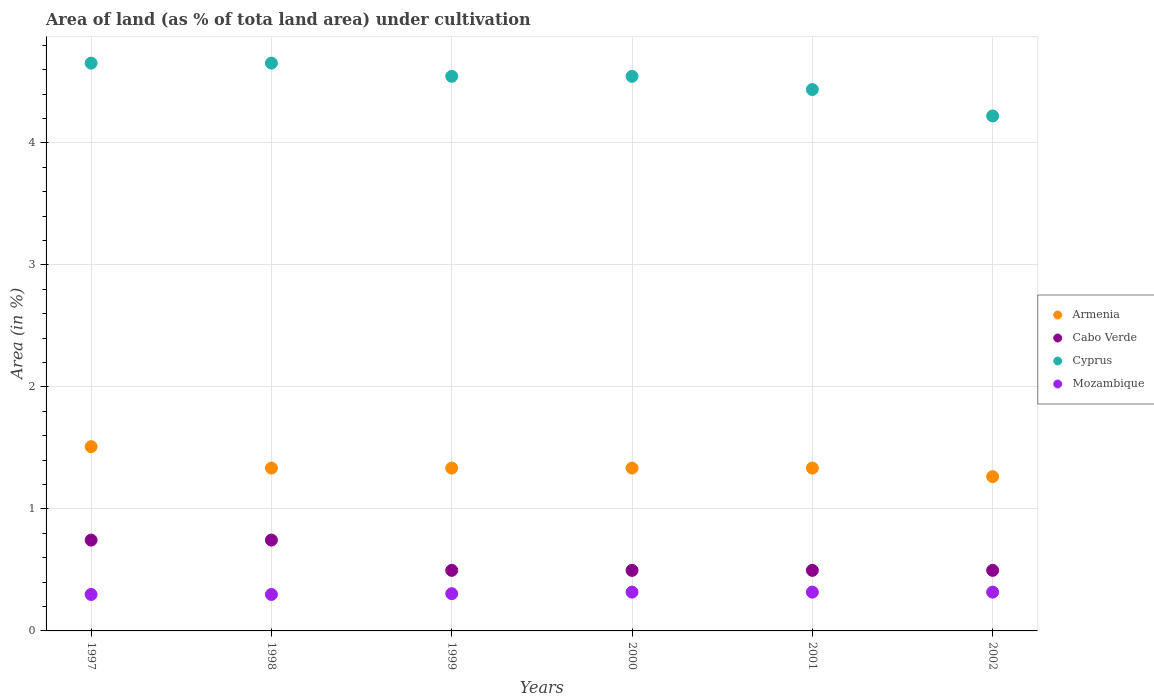What is the percentage of land under cultivation in Mozambique in 1997?
Make the answer very short. 0.3. Across all years, what is the maximum percentage of land under cultivation in Cyprus?
Provide a succinct answer. 4.65. Across all years, what is the minimum percentage of land under cultivation in Cyprus?
Your answer should be compact. 4.22. What is the total percentage of land under cultivation in Armenia in the graph?
Offer a terse response. 8.11. What is the difference between the percentage of land under cultivation in Mozambique in 1997 and that in 2002?
Your answer should be compact. -0.02. What is the difference between the percentage of land under cultivation in Cyprus in 1998 and the percentage of land under cultivation in Cabo Verde in 2000?
Your answer should be compact. 4.16. What is the average percentage of land under cultivation in Armenia per year?
Give a very brief answer. 1.35. In the year 1998, what is the difference between the percentage of land under cultivation in Mozambique and percentage of land under cultivation in Cyprus?
Give a very brief answer. -4.35. What is the ratio of the percentage of land under cultivation in Cabo Verde in 1999 to that in 2000?
Your answer should be compact. 1. What is the difference between the highest and the second highest percentage of land under cultivation in Armenia?
Provide a succinct answer. 0.18. What is the difference between the highest and the lowest percentage of land under cultivation in Mozambique?
Provide a succinct answer. 0.02. In how many years, is the percentage of land under cultivation in Mozambique greater than the average percentage of land under cultivation in Mozambique taken over all years?
Make the answer very short. 3. Is the sum of the percentage of land under cultivation in Cabo Verde in 1997 and 1998 greater than the maximum percentage of land under cultivation in Mozambique across all years?
Provide a short and direct response. Yes. Is the percentage of land under cultivation in Armenia strictly greater than the percentage of land under cultivation in Cabo Verde over the years?
Give a very brief answer. Yes. How many years are there in the graph?
Keep it short and to the point. 6. What is the difference between two consecutive major ticks on the Y-axis?
Your answer should be very brief. 1. Are the values on the major ticks of Y-axis written in scientific E-notation?
Provide a short and direct response. No. Does the graph contain grids?
Your response must be concise. Yes. Where does the legend appear in the graph?
Offer a very short reply. Center right. How are the legend labels stacked?
Make the answer very short. Vertical. What is the title of the graph?
Make the answer very short. Area of land (as % of tota land area) under cultivation. Does "San Marino" appear as one of the legend labels in the graph?
Provide a short and direct response. No. What is the label or title of the Y-axis?
Offer a terse response. Area (in %). What is the Area (in %) of Armenia in 1997?
Provide a short and direct response. 1.51. What is the Area (in %) in Cabo Verde in 1997?
Your answer should be compact. 0.74. What is the Area (in %) of Cyprus in 1997?
Your answer should be compact. 4.65. What is the Area (in %) of Mozambique in 1997?
Keep it short and to the point. 0.3. What is the Area (in %) in Armenia in 1998?
Offer a terse response. 1.33. What is the Area (in %) of Cabo Verde in 1998?
Your response must be concise. 0.74. What is the Area (in %) in Cyprus in 1998?
Your answer should be compact. 4.65. What is the Area (in %) in Mozambique in 1998?
Offer a terse response. 0.3. What is the Area (in %) in Armenia in 1999?
Offer a very short reply. 1.33. What is the Area (in %) of Cabo Verde in 1999?
Ensure brevity in your answer.  0.5. What is the Area (in %) of Cyprus in 1999?
Give a very brief answer. 4.55. What is the Area (in %) in Mozambique in 1999?
Provide a short and direct response. 0.31. What is the Area (in %) of Armenia in 2000?
Your answer should be compact. 1.33. What is the Area (in %) of Cabo Verde in 2000?
Make the answer very short. 0.5. What is the Area (in %) of Cyprus in 2000?
Ensure brevity in your answer.  4.55. What is the Area (in %) of Mozambique in 2000?
Ensure brevity in your answer.  0.32. What is the Area (in %) of Armenia in 2001?
Give a very brief answer. 1.33. What is the Area (in %) of Cabo Verde in 2001?
Your answer should be compact. 0.5. What is the Area (in %) in Cyprus in 2001?
Give a very brief answer. 4.44. What is the Area (in %) in Mozambique in 2001?
Provide a succinct answer. 0.32. What is the Area (in %) in Armenia in 2002?
Make the answer very short. 1.26. What is the Area (in %) in Cabo Verde in 2002?
Offer a very short reply. 0.5. What is the Area (in %) in Cyprus in 2002?
Provide a short and direct response. 4.22. What is the Area (in %) of Mozambique in 2002?
Keep it short and to the point. 0.32. Across all years, what is the maximum Area (in %) of Armenia?
Provide a succinct answer. 1.51. Across all years, what is the maximum Area (in %) in Cabo Verde?
Offer a terse response. 0.74. Across all years, what is the maximum Area (in %) in Cyprus?
Offer a very short reply. 4.65. Across all years, what is the maximum Area (in %) of Mozambique?
Offer a terse response. 0.32. Across all years, what is the minimum Area (in %) in Armenia?
Ensure brevity in your answer.  1.26. Across all years, what is the minimum Area (in %) of Cabo Verde?
Keep it short and to the point. 0.5. Across all years, what is the minimum Area (in %) in Cyprus?
Keep it short and to the point. 4.22. Across all years, what is the minimum Area (in %) of Mozambique?
Give a very brief answer. 0.3. What is the total Area (in %) in Armenia in the graph?
Offer a terse response. 8.11. What is the total Area (in %) of Cabo Verde in the graph?
Your answer should be very brief. 3.47. What is the total Area (in %) in Cyprus in the graph?
Your response must be concise. 27.06. What is the total Area (in %) in Mozambique in the graph?
Your answer should be compact. 1.86. What is the difference between the Area (in %) of Armenia in 1997 and that in 1998?
Give a very brief answer. 0.18. What is the difference between the Area (in %) in Armenia in 1997 and that in 1999?
Provide a short and direct response. 0.18. What is the difference between the Area (in %) of Cabo Verde in 1997 and that in 1999?
Offer a very short reply. 0.25. What is the difference between the Area (in %) in Cyprus in 1997 and that in 1999?
Your response must be concise. 0.11. What is the difference between the Area (in %) of Mozambique in 1997 and that in 1999?
Provide a succinct answer. -0.01. What is the difference between the Area (in %) in Armenia in 1997 and that in 2000?
Give a very brief answer. 0.18. What is the difference between the Area (in %) in Cabo Verde in 1997 and that in 2000?
Provide a short and direct response. 0.25. What is the difference between the Area (in %) of Cyprus in 1997 and that in 2000?
Your response must be concise. 0.11. What is the difference between the Area (in %) of Mozambique in 1997 and that in 2000?
Offer a terse response. -0.02. What is the difference between the Area (in %) in Armenia in 1997 and that in 2001?
Keep it short and to the point. 0.18. What is the difference between the Area (in %) in Cabo Verde in 1997 and that in 2001?
Your answer should be compact. 0.25. What is the difference between the Area (in %) of Cyprus in 1997 and that in 2001?
Your answer should be very brief. 0.22. What is the difference between the Area (in %) in Mozambique in 1997 and that in 2001?
Give a very brief answer. -0.02. What is the difference between the Area (in %) of Armenia in 1997 and that in 2002?
Ensure brevity in your answer.  0.25. What is the difference between the Area (in %) of Cabo Verde in 1997 and that in 2002?
Your answer should be compact. 0.25. What is the difference between the Area (in %) of Cyprus in 1997 and that in 2002?
Your response must be concise. 0.43. What is the difference between the Area (in %) of Mozambique in 1997 and that in 2002?
Make the answer very short. -0.02. What is the difference between the Area (in %) in Armenia in 1998 and that in 1999?
Your response must be concise. 0. What is the difference between the Area (in %) of Cabo Verde in 1998 and that in 1999?
Ensure brevity in your answer.  0.25. What is the difference between the Area (in %) in Cyprus in 1998 and that in 1999?
Offer a very short reply. 0.11. What is the difference between the Area (in %) in Mozambique in 1998 and that in 1999?
Give a very brief answer. -0.01. What is the difference between the Area (in %) in Cabo Verde in 1998 and that in 2000?
Your response must be concise. 0.25. What is the difference between the Area (in %) in Cyprus in 1998 and that in 2000?
Your response must be concise. 0.11. What is the difference between the Area (in %) in Mozambique in 1998 and that in 2000?
Provide a succinct answer. -0.02. What is the difference between the Area (in %) in Armenia in 1998 and that in 2001?
Offer a terse response. 0. What is the difference between the Area (in %) in Cabo Verde in 1998 and that in 2001?
Offer a terse response. 0.25. What is the difference between the Area (in %) in Cyprus in 1998 and that in 2001?
Offer a terse response. 0.22. What is the difference between the Area (in %) of Mozambique in 1998 and that in 2001?
Provide a succinct answer. -0.02. What is the difference between the Area (in %) of Armenia in 1998 and that in 2002?
Give a very brief answer. 0.07. What is the difference between the Area (in %) in Cabo Verde in 1998 and that in 2002?
Offer a terse response. 0.25. What is the difference between the Area (in %) in Cyprus in 1998 and that in 2002?
Provide a short and direct response. 0.43. What is the difference between the Area (in %) in Mozambique in 1998 and that in 2002?
Offer a terse response. -0.02. What is the difference between the Area (in %) in Armenia in 1999 and that in 2000?
Make the answer very short. 0. What is the difference between the Area (in %) in Cabo Verde in 1999 and that in 2000?
Your answer should be very brief. 0. What is the difference between the Area (in %) in Cyprus in 1999 and that in 2000?
Give a very brief answer. 0. What is the difference between the Area (in %) of Mozambique in 1999 and that in 2000?
Your answer should be very brief. -0.01. What is the difference between the Area (in %) in Armenia in 1999 and that in 2001?
Make the answer very short. 0. What is the difference between the Area (in %) of Cabo Verde in 1999 and that in 2001?
Provide a succinct answer. 0. What is the difference between the Area (in %) of Cyprus in 1999 and that in 2001?
Offer a very short reply. 0.11. What is the difference between the Area (in %) in Mozambique in 1999 and that in 2001?
Your answer should be compact. -0.01. What is the difference between the Area (in %) in Armenia in 1999 and that in 2002?
Your answer should be very brief. 0.07. What is the difference between the Area (in %) in Cyprus in 1999 and that in 2002?
Give a very brief answer. 0.32. What is the difference between the Area (in %) of Mozambique in 1999 and that in 2002?
Provide a short and direct response. -0.01. What is the difference between the Area (in %) of Cyprus in 2000 and that in 2001?
Your answer should be compact. 0.11. What is the difference between the Area (in %) in Mozambique in 2000 and that in 2001?
Ensure brevity in your answer.  0. What is the difference between the Area (in %) of Armenia in 2000 and that in 2002?
Offer a very short reply. 0.07. What is the difference between the Area (in %) of Cyprus in 2000 and that in 2002?
Offer a terse response. 0.32. What is the difference between the Area (in %) of Armenia in 2001 and that in 2002?
Provide a short and direct response. 0.07. What is the difference between the Area (in %) in Cyprus in 2001 and that in 2002?
Offer a terse response. 0.22. What is the difference between the Area (in %) in Mozambique in 2001 and that in 2002?
Your answer should be compact. 0. What is the difference between the Area (in %) of Armenia in 1997 and the Area (in %) of Cabo Verde in 1998?
Offer a terse response. 0.77. What is the difference between the Area (in %) of Armenia in 1997 and the Area (in %) of Cyprus in 1998?
Your answer should be compact. -3.14. What is the difference between the Area (in %) of Armenia in 1997 and the Area (in %) of Mozambique in 1998?
Provide a short and direct response. 1.21. What is the difference between the Area (in %) of Cabo Verde in 1997 and the Area (in %) of Cyprus in 1998?
Ensure brevity in your answer.  -3.91. What is the difference between the Area (in %) of Cabo Verde in 1997 and the Area (in %) of Mozambique in 1998?
Provide a succinct answer. 0.45. What is the difference between the Area (in %) of Cyprus in 1997 and the Area (in %) of Mozambique in 1998?
Offer a terse response. 4.35. What is the difference between the Area (in %) in Armenia in 1997 and the Area (in %) in Cabo Verde in 1999?
Offer a terse response. 1.01. What is the difference between the Area (in %) in Armenia in 1997 and the Area (in %) in Cyprus in 1999?
Your response must be concise. -3.04. What is the difference between the Area (in %) of Armenia in 1997 and the Area (in %) of Mozambique in 1999?
Provide a succinct answer. 1.21. What is the difference between the Area (in %) in Cabo Verde in 1997 and the Area (in %) in Cyprus in 1999?
Your answer should be compact. -3.8. What is the difference between the Area (in %) of Cabo Verde in 1997 and the Area (in %) of Mozambique in 1999?
Ensure brevity in your answer.  0.44. What is the difference between the Area (in %) in Cyprus in 1997 and the Area (in %) in Mozambique in 1999?
Provide a short and direct response. 4.35. What is the difference between the Area (in %) of Armenia in 1997 and the Area (in %) of Cabo Verde in 2000?
Offer a very short reply. 1.01. What is the difference between the Area (in %) in Armenia in 1997 and the Area (in %) in Cyprus in 2000?
Offer a very short reply. -3.04. What is the difference between the Area (in %) of Armenia in 1997 and the Area (in %) of Mozambique in 2000?
Offer a terse response. 1.19. What is the difference between the Area (in %) in Cabo Verde in 1997 and the Area (in %) in Cyprus in 2000?
Provide a succinct answer. -3.8. What is the difference between the Area (in %) of Cabo Verde in 1997 and the Area (in %) of Mozambique in 2000?
Provide a short and direct response. 0.43. What is the difference between the Area (in %) in Cyprus in 1997 and the Area (in %) in Mozambique in 2000?
Provide a succinct answer. 4.34. What is the difference between the Area (in %) in Armenia in 1997 and the Area (in %) in Cabo Verde in 2001?
Your response must be concise. 1.01. What is the difference between the Area (in %) of Armenia in 1997 and the Area (in %) of Cyprus in 2001?
Your answer should be compact. -2.93. What is the difference between the Area (in %) in Armenia in 1997 and the Area (in %) in Mozambique in 2001?
Give a very brief answer. 1.19. What is the difference between the Area (in %) of Cabo Verde in 1997 and the Area (in %) of Cyprus in 2001?
Offer a terse response. -3.69. What is the difference between the Area (in %) of Cabo Verde in 1997 and the Area (in %) of Mozambique in 2001?
Give a very brief answer. 0.43. What is the difference between the Area (in %) of Cyprus in 1997 and the Area (in %) of Mozambique in 2001?
Provide a succinct answer. 4.34. What is the difference between the Area (in %) of Armenia in 1997 and the Area (in %) of Cabo Verde in 2002?
Offer a terse response. 1.01. What is the difference between the Area (in %) of Armenia in 1997 and the Area (in %) of Cyprus in 2002?
Provide a succinct answer. -2.71. What is the difference between the Area (in %) in Armenia in 1997 and the Area (in %) in Mozambique in 2002?
Provide a short and direct response. 1.19. What is the difference between the Area (in %) in Cabo Verde in 1997 and the Area (in %) in Cyprus in 2002?
Ensure brevity in your answer.  -3.48. What is the difference between the Area (in %) of Cabo Verde in 1997 and the Area (in %) of Mozambique in 2002?
Your answer should be very brief. 0.43. What is the difference between the Area (in %) in Cyprus in 1997 and the Area (in %) in Mozambique in 2002?
Ensure brevity in your answer.  4.34. What is the difference between the Area (in %) of Armenia in 1998 and the Area (in %) of Cabo Verde in 1999?
Keep it short and to the point. 0.84. What is the difference between the Area (in %) of Armenia in 1998 and the Area (in %) of Cyprus in 1999?
Offer a very short reply. -3.21. What is the difference between the Area (in %) of Armenia in 1998 and the Area (in %) of Mozambique in 1999?
Ensure brevity in your answer.  1.03. What is the difference between the Area (in %) in Cabo Verde in 1998 and the Area (in %) in Cyprus in 1999?
Offer a terse response. -3.8. What is the difference between the Area (in %) in Cabo Verde in 1998 and the Area (in %) in Mozambique in 1999?
Provide a succinct answer. 0.44. What is the difference between the Area (in %) of Cyprus in 1998 and the Area (in %) of Mozambique in 1999?
Your response must be concise. 4.35. What is the difference between the Area (in %) of Armenia in 1998 and the Area (in %) of Cabo Verde in 2000?
Offer a terse response. 0.84. What is the difference between the Area (in %) in Armenia in 1998 and the Area (in %) in Cyprus in 2000?
Provide a succinct answer. -3.21. What is the difference between the Area (in %) in Armenia in 1998 and the Area (in %) in Mozambique in 2000?
Offer a very short reply. 1.02. What is the difference between the Area (in %) of Cabo Verde in 1998 and the Area (in %) of Cyprus in 2000?
Keep it short and to the point. -3.8. What is the difference between the Area (in %) in Cabo Verde in 1998 and the Area (in %) in Mozambique in 2000?
Keep it short and to the point. 0.43. What is the difference between the Area (in %) of Cyprus in 1998 and the Area (in %) of Mozambique in 2000?
Ensure brevity in your answer.  4.34. What is the difference between the Area (in %) in Armenia in 1998 and the Area (in %) in Cabo Verde in 2001?
Your answer should be very brief. 0.84. What is the difference between the Area (in %) of Armenia in 1998 and the Area (in %) of Cyprus in 2001?
Give a very brief answer. -3.1. What is the difference between the Area (in %) of Armenia in 1998 and the Area (in %) of Mozambique in 2001?
Your answer should be compact. 1.02. What is the difference between the Area (in %) in Cabo Verde in 1998 and the Area (in %) in Cyprus in 2001?
Your answer should be compact. -3.69. What is the difference between the Area (in %) of Cabo Verde in 1998 and the Area (in %) of Mozambique in 2001?
Provide a succinct answer. 0.43. What is the difference between the Area (in %) in Cyprus in 1998 and the Area (in %) in Mozambique in 2001?
Keep it short and to the point. 4.34. What is the difference between the Area (in %) in Armenia in 1998 and the Area (in %) in Cabo Verde in 2002?
Give a very brief answer. 0.84. What is the difference between the Area (in %) of Armenia in 1998 and the Area (in %) of Cyprus in 2002?
Offer a very short reply. -2.89. What is the difference between the Area (in %) of Armenia in 1998 and the Area (in %) of Mozambique in 2002?
Make the answer very short. 1.02. What is the difference between the Area (in %) in Cabo Verde in 1998 and the Area (in %) in Cyprus in 2002?
Your response must be concise. -3.48. What is the difference between the Area (in %) in Cabo Verde in 1998 and the Area (in %) in Mozambique in 2002?
Your answer should be compact. 0.43. What is the difference between the Area (in %) of Cyprus in 1998 and the Area (in %) of Mozambique in 2002?
Your answer should be very brief. 4.34. What is the difference between the Area (in %) in Armenia in 1999 and the Area (in %) in Cabo Verde in 2000?
Give a very brief answer. 0.84. What is the difference between the Area (in %) in Armenia in 1999 and the Area (in %) in Cyprus in 2000?
Your response must be concise. -3.21. What is the difference between the Area (in %) in Armenia in 1999 and the Area (in %) in Mozambique in 2000?
Your response must be concise. 1.02. What is the difference between the Area (in %) in Cabo Verde in 1999 and the Area (in %) in Cyprus in 2000?
Give a very brief answer. -4.05. What is the difference between the Area (in %) of Cabo Verde in 1999 and the Area (in %) of Mozambique in 2000?
Your answer should be compact. 0.18. What is the difference between the Area (in %) of Cyprus in 1999 and the Area (in %) of Mozambique in 2000?
Offer a very short reply. 4.23. What is the difference between the Area (in %) of Armenia in 1999 and the Area (in %) of Cabo Verde in 2001?
Your response must be concise. 0.84. What is the difference between the Area (in %) of Armenia in 1999 and the Area (in %) of Cyprus in 2001?
Offer a terse response. -3.1. What is the difference between the Area (in %) in Armenia in 1999 and the Area (in %) in Mozambique in 2001?
Make the answer very short. 1.02. What is the difference between the Area (in %) in Cabo Verde in 1999 and the Area (in %) in Cyprus in 2001?
Ensure brevity in your answer.  -3.94. What is the difference between the Area (in %) of Cabo Verde in 1999 and the Area (in %) of Mozambique in 2001?
Provide a short and direct response. 0.18. What is the difference between the Area (in %) in Cyprus in 1999 and the Area (in %) in Mozambique in 2001?
Provide a short and direct response. 4.23. What is the difference between the Area (in %) of Armenia in 1999 and the Area (in %) of Cabo Verde in 2002?
Ensure brevity in your answer.  0.84. What is the difference between the Area (in %) of Armenia in 1999 and the Area (in %) of Cyprus in 2002?
Provide a succinct answer. -2.89. What is the difference between the Area (in %) of Armenia in 1999 and the Area (in %) of Mozambique in 2002?
Offer a very short reply. 1.02. What is the difference between the Area (in %) in Cabo Verde in 1999 and the Area (in %) in Cyprus in 2002?
Your answer should be compact. -3.72. What is the difference between the Area (in %) of Cabo Verde in 1999 and the Area (in %) of Mozambique in 2002?
Keep it short and to the point. 0.18. What is the difference between the Area (in %) in Cyprus in 1999 and the Area (in %) in Mozambique in 2002?
Offer a very short reply. 4.23. What is the difference between the Area (in %) of Armenia in 2000 and the Area (in %) of Cabo Verde in 2001?
Make the answer very short. 0.84. What is the difference between the Area (in %) in Armenia in 2000 and the Area (in %) in Cyprus in 2001?
Provide a succinct answer. -3.1. What is the difference between the Area (in %) of Armenia in 2000 and the Area (in %) of Mozambique in 2001?
Offer a very short reply. 1.02. What is the difference between the Area (in %) in Cabo Verde in 2000 and the Area (in %) in Cyprus in 2001?
Provide a short and direct response. -3.94. What is the difference between the Area (in %) of Cabo Verde in 2000 and the Area (in %) of Mozambique in 2001?
Offer a terse response. 0.18. What is the difference between the Area (in %) of Cyprus in 2000 and the Area (in %) of Mozambique in 2001?
Your response must be concise. 4.23. What is the difference between the Area (in %) in Armenia in 2000 and the Area (in %) in Cabo Verde in 2002?
Provide a succinct answer. 0.84. What is the difference between the Area (in %) of Armenia in 2000 and the Area (in %) of Cyprus in 2002?
Your answer should be very brief. -2.89. What is the difference between the Area (in %) of Armenia in 2000 and the Area (in %) of Mozambique in 2002?
Give a very brief answer. 1.02. What is the difference between the Area (in %) of Cabo Verde in 2000 and the Area (in %) of Cyprus in 2002?
Your answer should be compact. -3.72. What is the difference between the Area (in %) of Cabo Verde in 2000 and the Area (in %) of Mozambique in 2002?
Provide a succinct answer. 0.18. What is the difference between the Area (in %) of Cyprus in 2000 and the Area (in %) of Mozambique in 2002?
Provide a short and direct response. 4.23. What is the difference between the Area (in %) in Armenia in 2001 and the Area (in %) in Cabo Verde in 2002?
Your answer should be very brief. 0.84. What is the difference between the Area (in %) in Armenia in 2001 and the Area (in %) in Cyprus in 2002?
Ensure brevity in your answer.  -2.89. What is the difference between the Area (in %) in Armenia in 2001 and the Area (in %) in Mozambique in 2002?
Provide a succinct answer. 1.02. What is the difference between the Area (in %) of Cabo Verde in 2001 and the Area (in %) of Cyprus in 2002?
Offer a very short reply. -3.72. What is the difference between the Area (in %) in Cabo Verde in 2001 and the Area (in %) in Mozambique in 2002?
Offer a very short reply. 0.18. What is the difference between the Area (in %) of Cyprus in 2001 and the Area (in %) of Mozambique in 2002?
Your answer should be compact. 4.12. What is the average Area (in %) in Armenia per year?
Your answer should be compact. 1.35. What is the average Area (in %) in Cabo Verde per year?
Make the answer very short. 0.58. What is the average Area (in %) of Cyprus per year?
Provide a short and direct response. 4.51. What is the average Area (in %) of Mozambique per year?
Give a very brief answer. 0.31. In the year 1997, what is the difference between the Area (in %) in Armenia and Area (in %) in Cabo Verde?
Offer a terse response. 0.77. In the year 1997, what is the difference between the Area (in %) in Armenia and Area (in %) in Cyprus?
Offer a very short reply. -3.14. In the year 1997, what is the difference between the Area (in %) in Armenia and Area (in %) in Mozambique?
Your answer should be compact. 1.21. In the year 1997, what is the difference between the Area (in %) in Cabo Verde and Area (in %) in Cyprus?
Your answer should be very brief. -3.91. In the year 1997, what is the difference between the Area (in %) in Cabo Verde and Area (in %) in Mozambique?
Give a very brief answer. 0.45. In the year 1997, what is the difference between the Area (in %) in Cyprus and Area (in %) in Mozambique?
Give a very brief answer. 4.35. In the year 1998, what is the difference between the Area (in %) in Armenia and Area (in %) in Cabo Verde?
Keep it short and to the point. 0.59. In the year 1998, what is the difference between the Area (in %) in Armenia and Area (in %) in Cyprus?
Give a very brief answer. -3.32. In the year 1998, what is the difference between the Area (in %) of Armenia and Area (in %) of Mozambique?
Provide a succinct answer. 1.04. In the year 1998, what is the difference between the Area (in %) in Cabo Verde and Area (in %) in Cyprus?
Give a very brief answer. -3.91. In the year 1998, what is the difference between the Area (in %) of Cabo Verde and Area (in %) of Mozambique?
Provide a short and direct response. 0.45. In the year 1998, what is the difference between the Area (in %) in Cyprus and Area (in %) in Mozambique?
Offer a terse response. 4.35. In the year 1999, what is the difference between the Area (in %) of Armenia and Area (in %) of Cabo Verde?
Provide a short and direct response. 0.84. In the year 1999, what is the difference between the Area (in %) of Armenia and Area (in %) of Cyprus?
Your response must be concise. -3.21. In the year 1999, what is the difference between the Area (in %) of Armenia and Area (in %) of Mozambique?
Provide a succinct answer. 1.03. In the year 1999, what is the difference between the Area (in %) of Cabo Verde and Area (in %) of Cyprus?
Your response must be concise. -4.05. In the year 1999, what is the difference between the Area (in %) in Cabo Verde and Area (in %) in Mozambique?
Provide a short and direct response. 0.19. In the year 1999, what is the difference between the Area (in %) in Cyprus and Area (in %) in Mozambique?
Your answer should be very brief. 4.24. In the year 2000, what is the difference between the Area (in %) of Armenia and Area (in %) of Cabo Verde?
Provide a short and direct response. 0.84. In the year 2000, what is the difference between the Area (in %) in Armenia and Area (in %) in Cyprus?
Ensure brevity in your answer.  -3.21. In the year 2000, what is the difference between the Area (in %) in Armenia and Area (in %) in Mozambique?
Ensure brevity in your answer.  1.02. In the year 2000, what is the difference between the Area (in %) in Cabo Verde and Area (in %) in Cyprus?
Your answer should be very brief. -4.05. In the year 2000, what is the difference between the Area (in %) in Cabo Verde and Area (in %) in Mozambique?
Provide a succinct answer. 0.18. In the year 2000, what is the difference between the Area (in %) of Cyprus and Area (in %) of Mozambique?
Give a very brief answer. 4.23. In the year 2001, what is the difference between the Area (in %) in Armenia and Area (in %) in Cabo Verde?
Offer a terse response. 0.84. In the year 2001, what is the difference between the Area (in %) of Armenia and Area (in %) of Cyprus?
Give a very brief answer. -3.1. In the year 2001, what is the difference between the Area (in %) of Armenia and Area (in %) of Mozambique?
Give a very brief answer. 1.02. In the year 2001, what is the difference between the Area (in %) in Cabo Verde and Area (in %) in Cyprus?
Offer a very short reply. -3.94. In the year 2001, what is the difference between the Area (in %) of Cabo Verde and Area (in %) of Mozambique?
Give a very brief answer. 0.18. In the year 2001, what is the difference between the Area (in %) in Cyprus and Area (in %) in Mozambique?
Offer a terse response. 4.12. In the year 2002, what is the difference between the Area (in %) in Armenia and Area (in %) in Cabo Verde?
Your answer should be compact. 0.77. In the year 2002, what is the difference between the Area (in %) in Armenia and Area (in %) in Cyprus?
Provide a short and direct response. -2.96. In the year 2002, what is the difference between the Area (in %) in Armenia and Area (in %) in Mozambique?
Provide a short and direct response. 0.95. In the year 2002, what is the difference between the Area (in %) in Cabo Verde and Area (in %) in Cyprus?
Make the answer very short. -3.72. In the year 2002, what is the difference between the Area (in %) of Cabo Verde and Area (in %) of Mozambique?
Provide a short and direct response. 0.18. In the year 2002, what is the difference between the Area (in %) of Cyprus and Area (in %) of Mozambique?
Offer a very short reply. 3.9. What is the ratio of the Area (in %) of Armenia in 1997 to that in 1998?
Provide a short and direct response. 1.13. What is the ratio of the Area (in %) of Cabo Verde in 1997 to that in 1998?
Keep it short and to the point. 1. What is the ratio of the Area (in %) of Cyprus in 1997 to that in 1998?
Offer a very short reply. 1. What is the ratio of the Area (in %) of Armenia in 1997 to that in 1999?
Your answer should be very brief. 1.13. What is the ratio of the Area (in %) of Cyprus in 1997 to that in 1999?
Offer a very short reply. 1.02. What is the ratio of the Area (in %) of Mozambique in 1997 to that in 1999?
Ensure brevity in your answer.  0.98. What is the ratio of the Area (in %) of Armenia in 1997 to that in 2000?
Your answer should be compact. 1.13. What is the ratio of the Area (in %) of Cabo Verde in 1997 to that in 2000?
Offer a terse response. 1.5. What is the ratio of the Area (in %) of Cyprus in 1997 to that in 2000?
Your response must be concise. 1.02. What is the ratio of the Area (in %) in Mozambique in 1997 to that in 2000?
Your answer should be compact. 0.94. What is the ratio of the Area (in %) in Armenia in 1997 to that in 2001?
Provide a succinct answer. 1.13. What is the ratio of the Area (in %) in Cabo Verde in 1997 to that in 2001?
Provide a short and direct response. 1.5. What is the ratio of the Area (in %) in Cyprus in 1997 to that in 2001?
Your response must be concise. 1.05. What is the ratio of the Area (in %) in Armenia in 1997 to that in 2002?
Offer a terse response. 1.19. What is the ratio of the Area (in %) of Cabo Verde in 1997 to that in 2002?
Your answer should be very brief. 1.5. What is the ratio of the Area (in %) in Cyprus in 1997 to that in 2002?
Keep it short and to the point. 1.1. What is the ratio of the Area (in %) of Mozambique in 1997 to that in 2002?
Ensure brevity in your answer.  0.94. What is the ratio of the Area (in %) in Armenia in 1998 to that in 1999?
Offer a terse response. 1. What is the ratio of the Area (in %) in Cabo Verde in 1998 to that in 1999?
Provide a short and direct response. 1.5. What is the ratio of the Area (in %) in Cyprus in 1998 to that in 1999?
Your answer should be very brief. 1.02. What is the ratio of the Area (in %) in Mozambique in 1998 to that in 1999?
Offer a very short reply. 0.98. What is the ratio of the Area (in %) in Cyprus in 1998 to that in 2000?
Your answer should be very brief. 1.02. What is the ratio of the Area (in %) in Mozambique in 1998 to that in 2000?
Keep it short and to the point. 0.94. What is the ratio of the Area (in %) of Cabo Verde in 1998 to that in 2001?
Provide a short and direct response. 1.5. What is the ratio of the Area (in %) in Cyprus in 1998 to that in 2001?
Offer a very short reply. 1.05. What is the ratio of the Area (in %) of Armenia in 1998 to that in 2002?
Make the answer very short. 1.06. What is the ratio of the Area (in %) of Cyprus in 1998 to that in 2002?
Your response must be concise. 1.1. What is the ratio of the Area (in %) of Mozambique in 1998 to that in 2002?
Your answer should be compact. 0.94. What is the ratio of the Area (in %) of Armenia in 1999 to that in 2000?
Your answer should be very brief. 1. What is the ratio of the Area (in %) of Armenia in 1999 to that in 2001?
Your answer should be compact. 1. What is the ratio of the Area (in %) of Cabo Verde in 1999 to that in 2001?
Provide a short and direct response. 1. What is the ratio of the Area (in %) in Cyprus in 1999 to that in 2001?
Your answer should be compact. 1.02. What is the ratio of the Area (in %) of Mozambique in 1999 to that in 2001?
Your answer should be compact. 0.96. What is the ratio of the Area (in %) in Armenia in 1999 to that in 2002?
Make the answer very short. 1.06. What is the ratio of the Area (in %) of Mozambique in 1999 to that in 2002?
Keep it short and to the point. 0.96. What is the ratio of the Area (in %) in Armenia in 2000 to that in 2001?
Offer a terse response. 1. What is the ratio of the Area (in %) in Cabo Verde in 2000 to that in 2001?
Make the answer very short. 1. What is the ratio of the Area (in %) in Cyprus in 2000 to that in 2001?
Keep it short and to the point. 1.02. What is the ratio of the Area (in %) of Armenia in 2000 to that in 2002?
Offer a very short reply. 1.06. What is the ratio of the Area (in %) of Mozambique in 2000 to that in 2002?
Your answer should be compact. 1. What is the ratio of the Area (in %) of Armenia in 2001 to that in 2002?
Provide a succinct answer. 1.06. What is the ratio of the Area (in %) in Cabo Verde in 2001 to that in 2002?
Your answer should be very brief. 1. What is the ratio of the Area (in %) of Cyprus in 2001 to that in 2002?
Offer a very short reply. 1.05. What is the difference between the highest and the second highest Area (in %) of Armenia?
Make the answer very short. 0.18. What is the difference between the highest and the second highest Area (in %) in Cabo Verde?
Provide a succinct answer. 0. What is the difference between the highest and the second highest Area (in %) in Cyprus?
Ensure brevity in your answer.  0. What is the difference between the highest and the second highest Area (in %) of Mozambique?
Your response must be concise. 0. What is the difference between the highest and the lowest Area (in %) of Armenia?
Offer a terse response. 0.25. What is the difference between the highest and the lowest Area (in %) of Cabo Verde?
Your answer should be very brief. 0.25. What is the difference between the highest and the lowest Area (in %) of Cyprus?
Offer a terse response. 0.43. What is the difference between the highest and the lowest Area (in %) of Mozambique?
Your answer should be very brief. 0.02. 